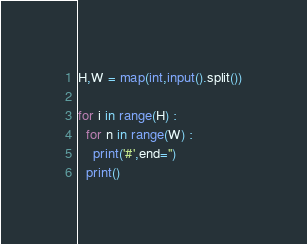Convert code to text. <code><loc_0><loc_0><loc_500><loc_500><_Python_>H,W = map(int,input().split())

for i in range(H) :
  for n in range(W) :
    print('#',end='')
  print()
</code> 